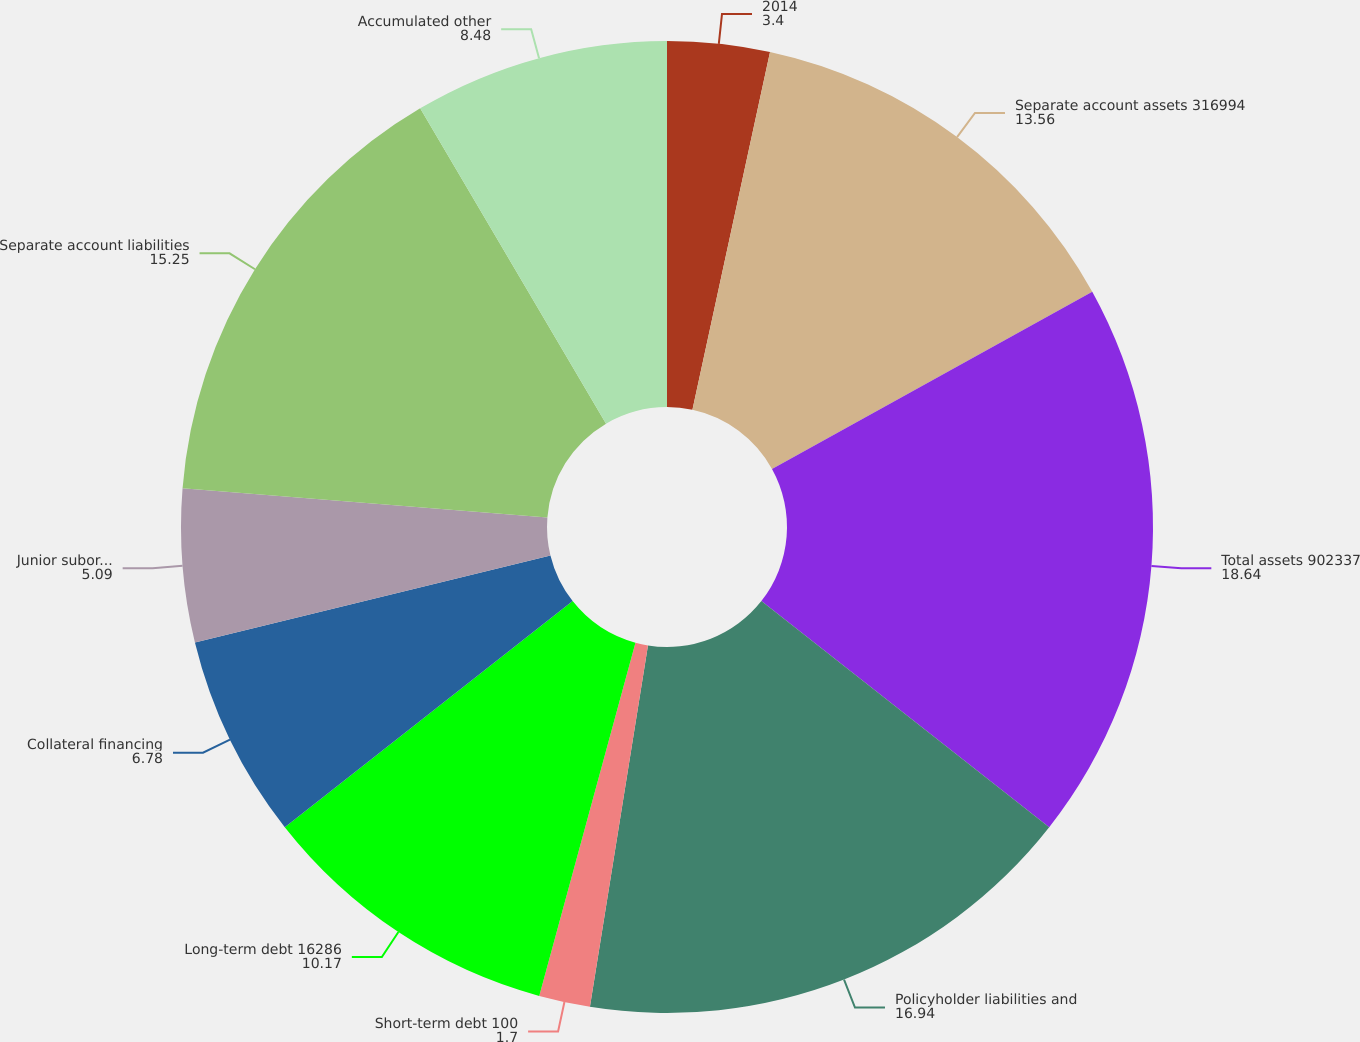<chart> <loc_0><loc_0><loc_500><loc_500><pie_chart><fcel>2014<fcel>Separate account assets 316994<fcel>Total assets 902337<fcel>Policyholder liabilities and<fcel>Short-term debt 100<fcel>Long-term debt 16286<fcel>Collateral financing<fcel>Junior subordinated debt<fcel>Separate account liabilities<fcel>Accumulated other<nl><fcel>3.4%<fcel>13.56%<fcel>18.64%<fcel>16.94%<fcel>1.7%<fcel>10.17%<fcel>6.78%<fcel>5.09%<fcel>15.25%<fcel>8.48%<nl></chart> 